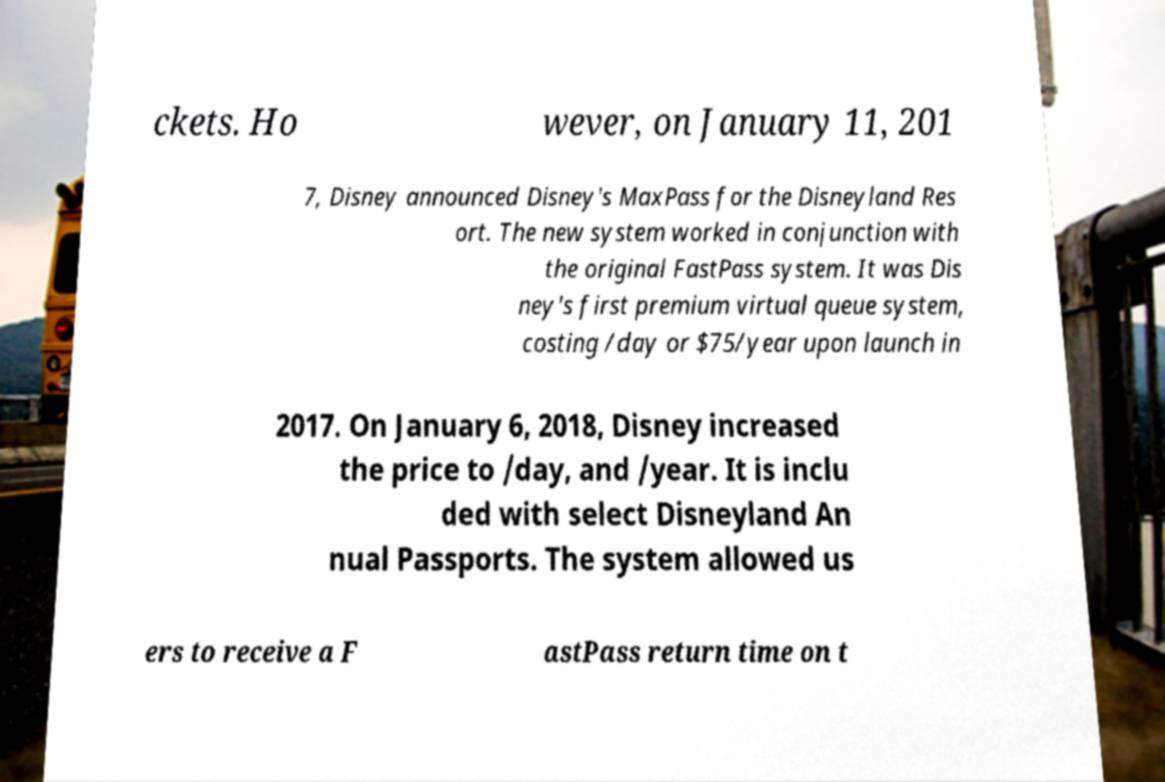Could you extract and type out the text from this image? ckets. Ho wever, on January 11, 201 7, Disney announced Disney's MaxPass for the Disneyland Res ort. The new system worked in conjunction with the original FastPass system. It was Dis ney's first premium virtual queue system, costing /day or $75/year upon launch in 2017. On January 6, 2018, Disney increased the price to /day, and /year. It is inclu ded with select Disneyland An nual Passports. The system allowed us ers to receive a F astPass return time on t 